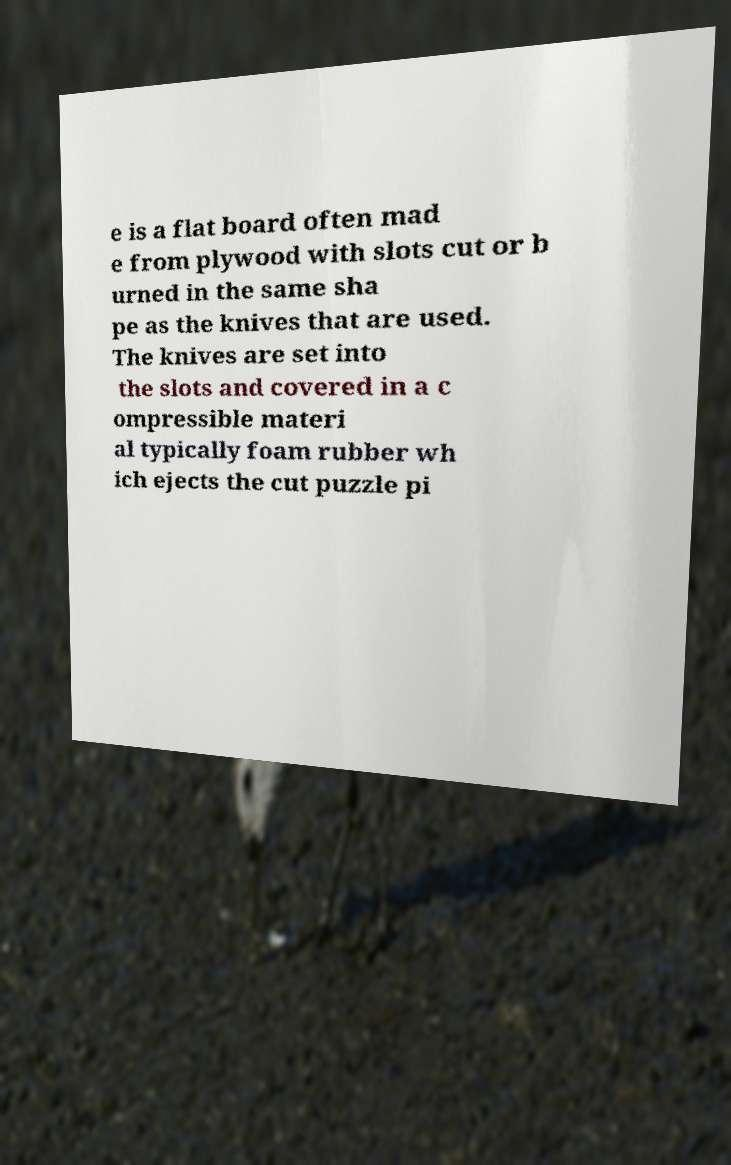Please read and relay the text visible in this image. What does it say? e is a flat board often mad e from plywood with slots cut or b urned in the same sha pe as the knives that are used. The knives are set into the slots and covered in a c ompressible materi al typically foam rubber wh ich ejects the cut puzzle pi 